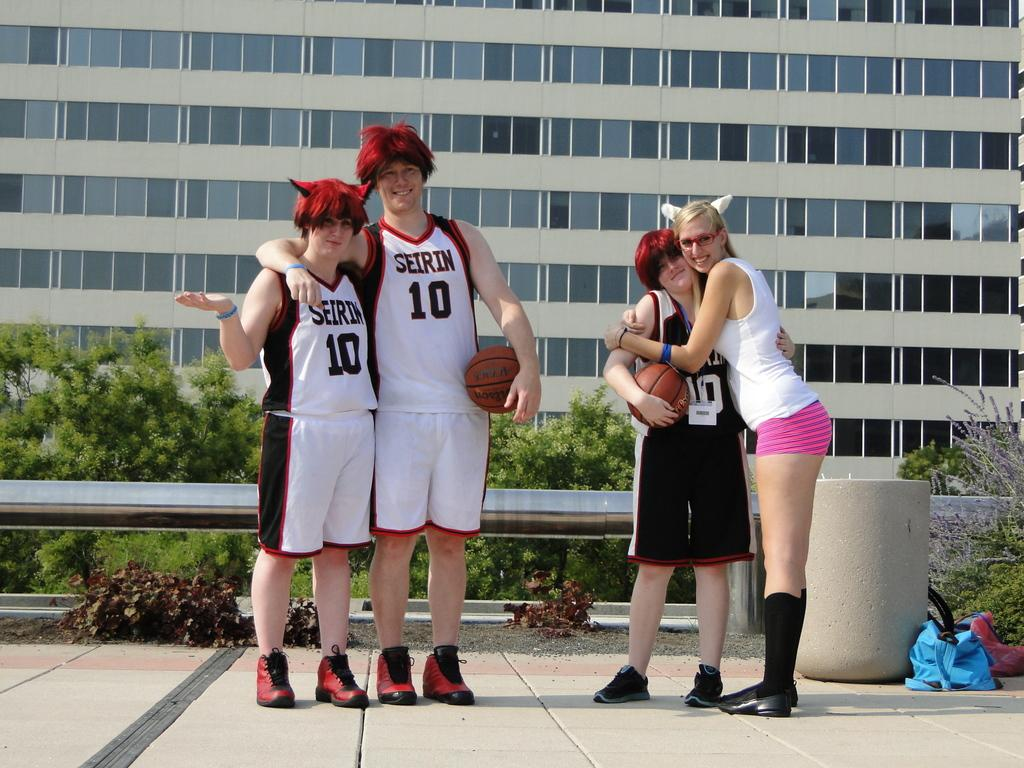<image>
Give a short and clear explanation of the subsequent image. Two kids are wearing matching jerseys with the number 10 on them. 